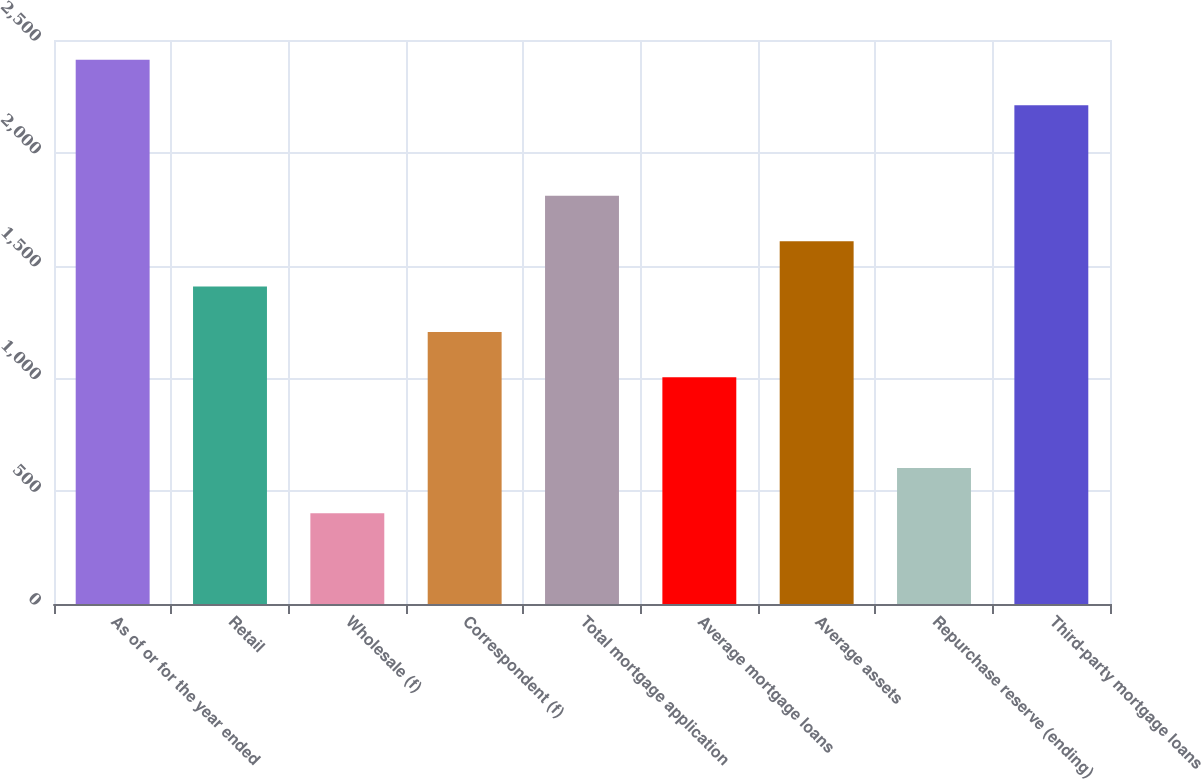Convert chart. <chart><loc_0><loc_0><loc_500><loc_500><bar_chart><fcel>As of or for the year ended<fcel>Retail<fcel>Wholesale (f)<fcel>Correspondent (f)<fcel>Total mortgage application<fcel>Average mortgage loans<fcel>Average assets<fcel>Repurchase reserve (ending)<fcel>Third-party mortgage loans<nl><fcel>2411.96<fcel>1407.16<fcel>402.36<fcel>1206.2<fcel>1809.08<fcel>1005.24<fcel>1608.12<fcel>603.32<fcel>2211<nl></chart> 